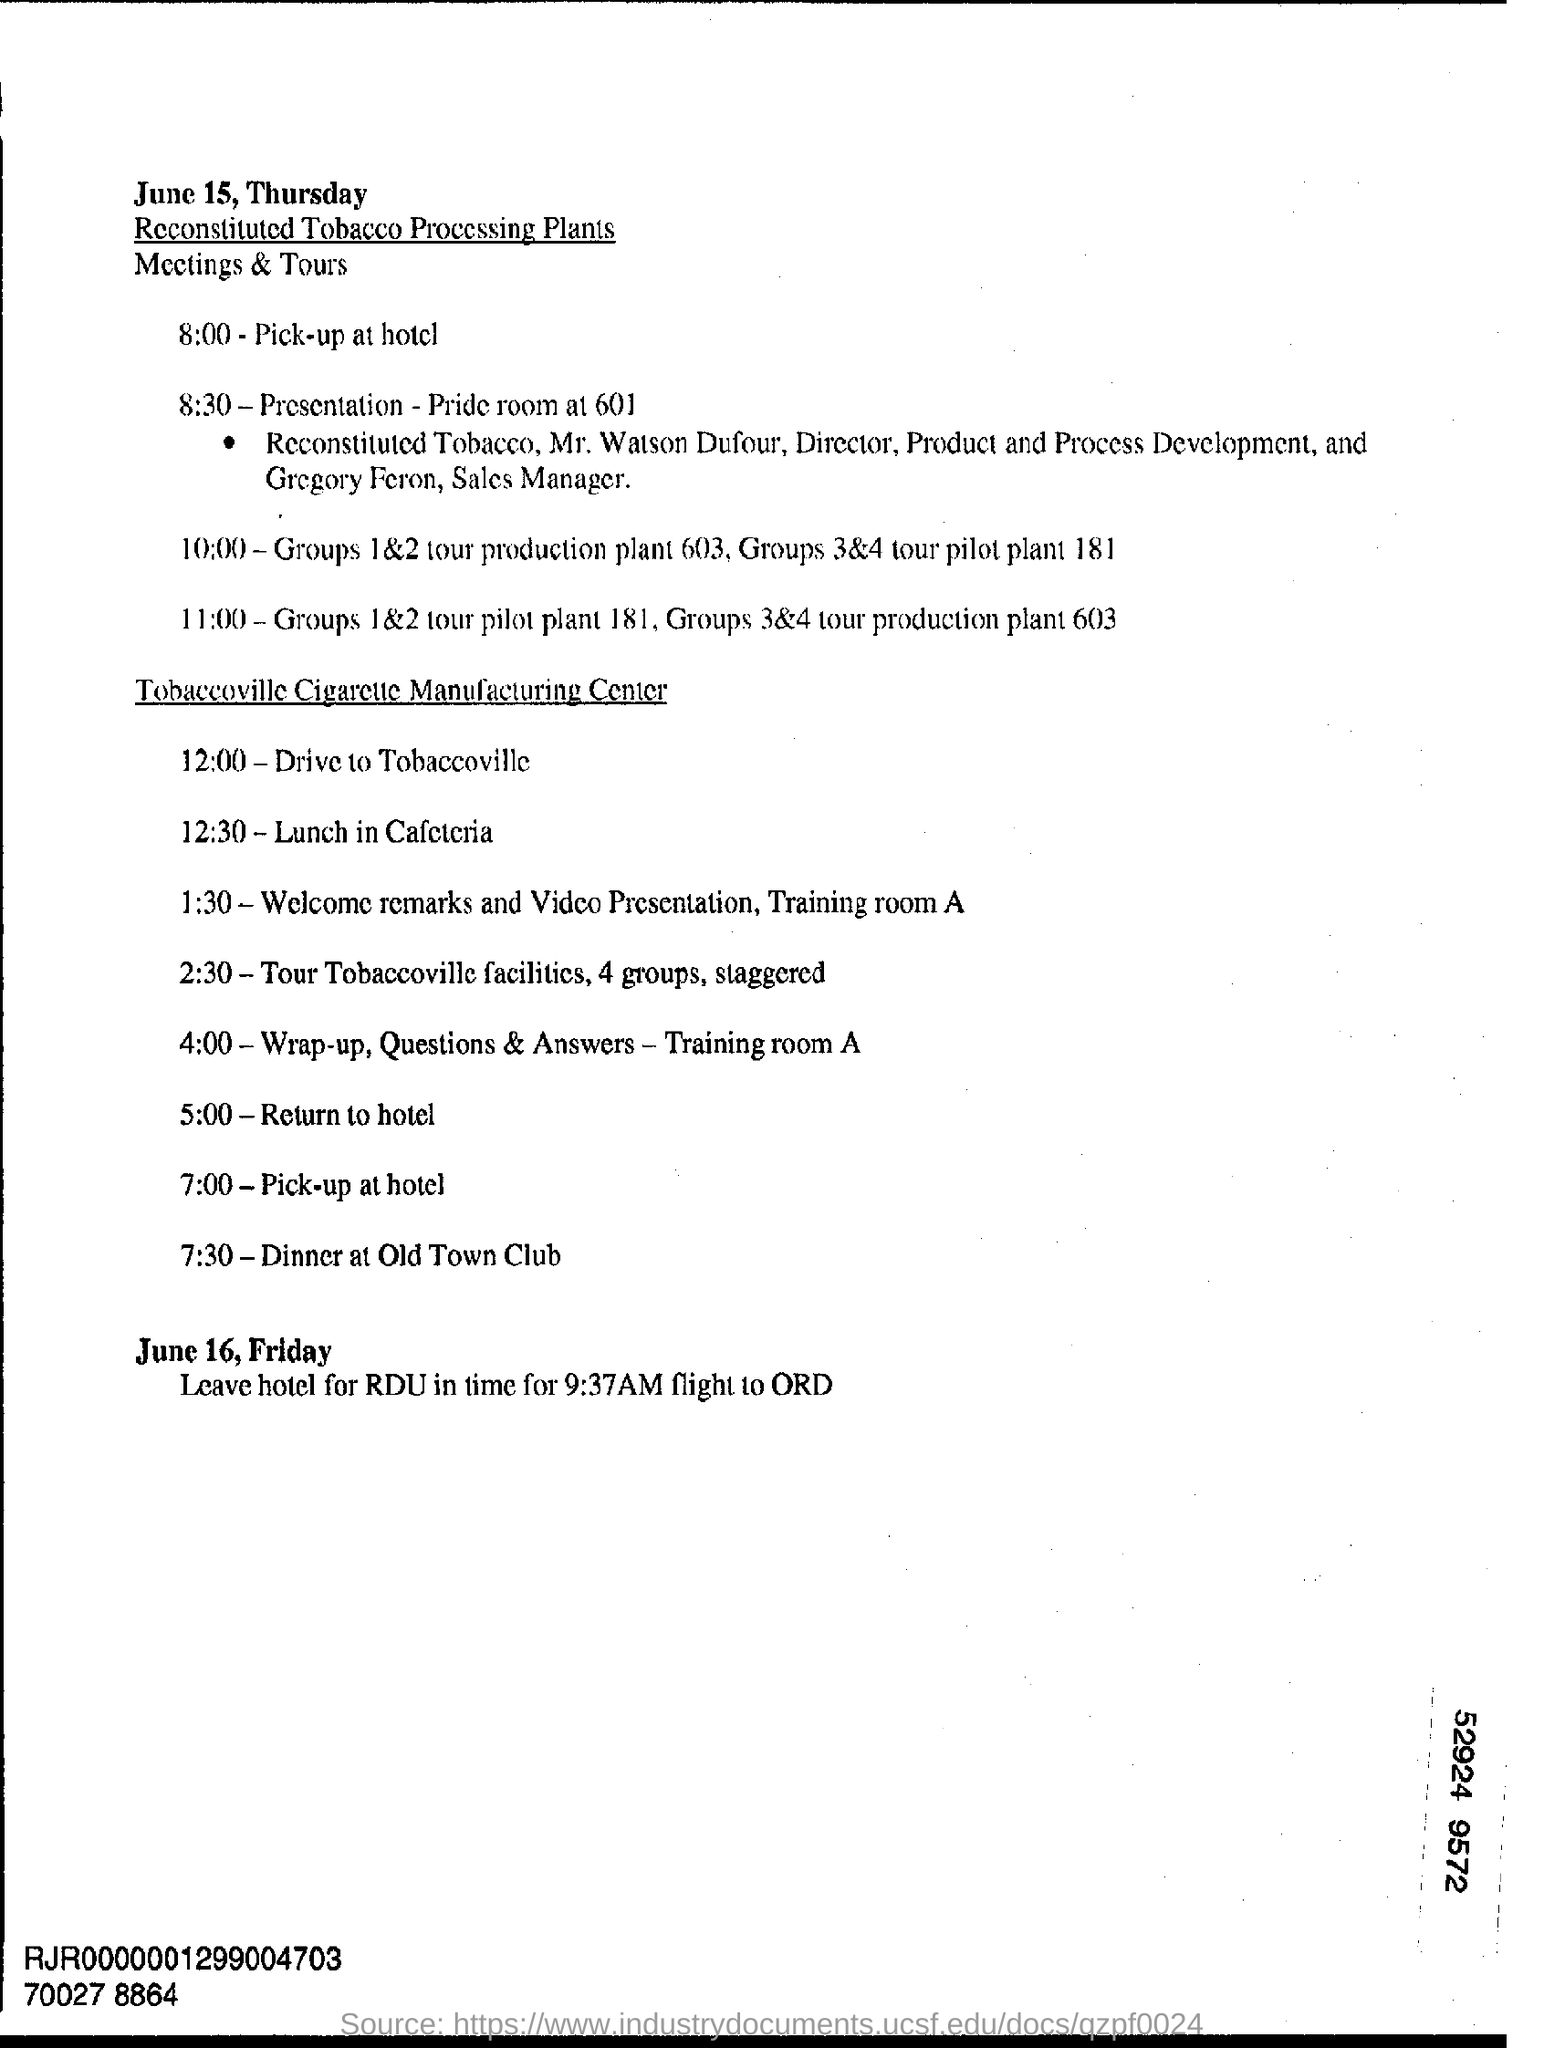When are they going to Drive to Tobaccoville?
Give a very brief answer. 12:00. What is their plan at 5:00?
Your answer should be very brief. Return to Hotel. 